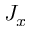Convert formula to latex. <formula><loc_0><loc_0><loc_500><loc_500>J _ { x }</formula> 